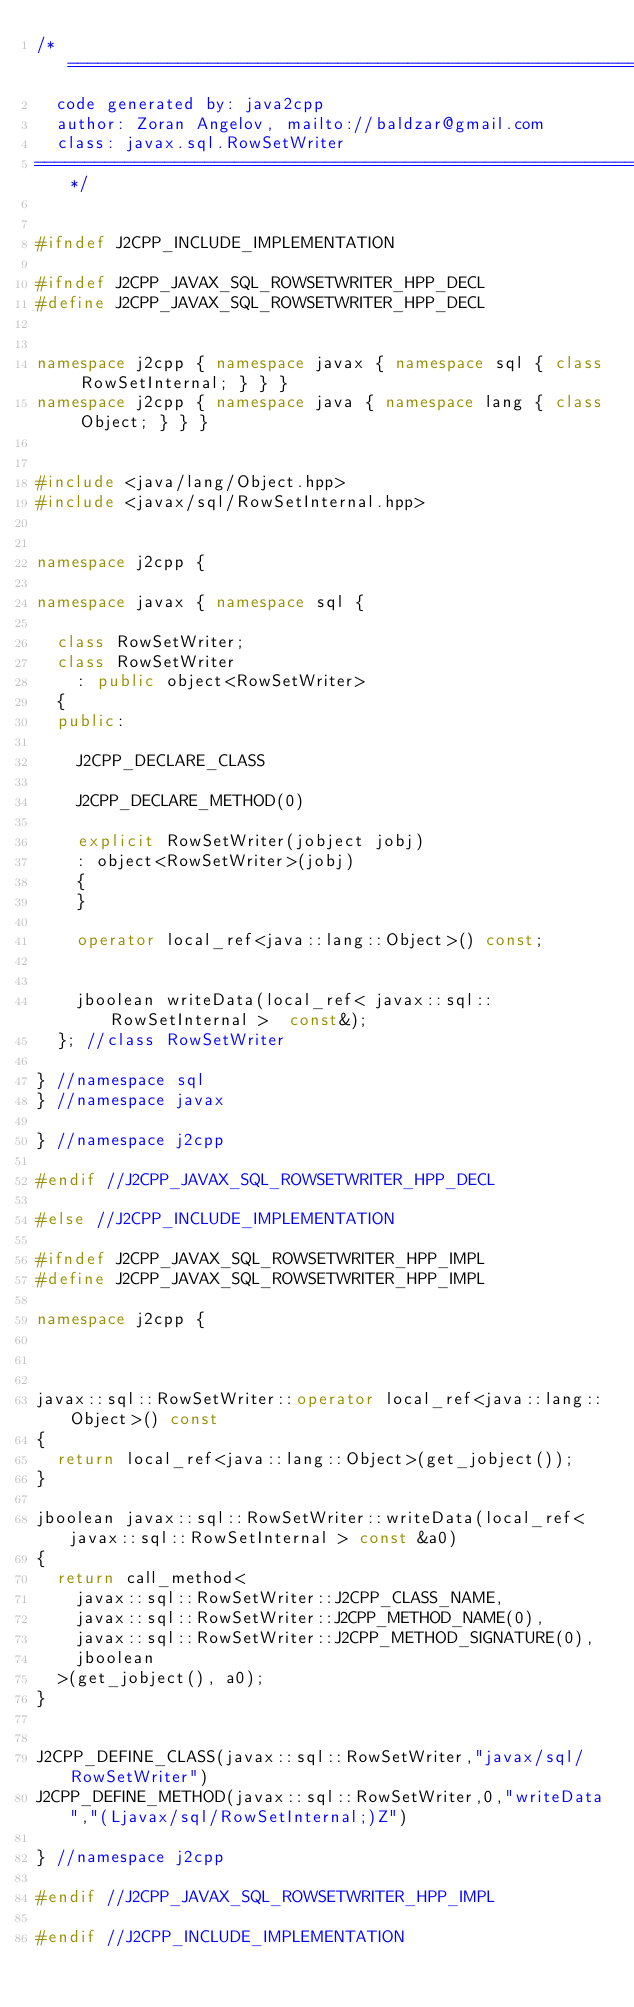Convert code to text. <code><loc_0><loc_0><loc_500><loc_500><_C++_>/*================================================================================
  code generated by: java2cpp
  author: Zoran Angelov, mailto://baldzar@gmail.com
  class: javax.sql.RowSetWriter
================================================================================*/


#ifndef J2CPP_INCLUDE_IMPLEMENTATION

#ifndef J2CPP_JAVAX_SQL_ROWSETWRITER_HPP_DECL
#define J2CPP_JAVAX_SQL_ROWSETWRITER_HPP_DECL


namespace j2cpp { namespace javax { namespace sql { class RowSetInternal; } } }
namespace j2cpp { namespace java { namespace lang { class Object; } } }


#include <java/lang/Object.hpp>
#include <javax/sql/RowSetInternal.hpp>


namespace j2cpp {

namespace javax { namespace sql {

	class RowSetWriter;
	class RowSetWriter
		: public object<RowSetWriter>
	{
	public:

		J2CPP_DECLARE_CLASS

		J2CPP_DECLARE_METHOD(0)

		explicit RowSetWriter(jobject jobj)
		: object<RowSetWriter>(jobj)
		{
		}

		operator local_ref<java::lang::Object>() const;


		jboolean writeData(local_ref< javax::sql::RowSetInternal >  const&);
	}; //class RowSetWriter

} //namespace sql
} //namespace javax

} //namespace j2cpp

#endif //J2CPP_JAVAX_SQL_ROWSETWRITER_HPP_DECL

#else //J2CPP_INCLUDE_IMPLEMENTATION

#ifndef J2CPP_JAVAX_SQL_ROWSETWRITER_HPP_IMPL
#define J2CPP_JAVAX_SQL_ROWSETWRITER_HPP_IMPL

namespace j2cpp {



javax::sql::RowSetWriter::operator local_ref<java::lang::Object>() const
{
	return local_ref<java::lang::Object>(get_jobject());
}

jboolean javax::sql::RowSetWriter::writeData(local_ref< javax::sql::RowSetInternal > const &a0)
{
	return call_method<
		javax::sql::RowSetWriter::J2CPP_CLASS_NAME,
		javax::sql::RowSetWriter::J2CPP_METHOD_NAME(0),
		javax::sql::RowSetWriter::J2CPP_METHOD_SIGNATURE(0), 
		jboolean
	>(get_jobject(), a0);
}


J2CPP_DEFINE_CLASS(javax::sql::RowSetWriter,"javax/sql/RowSetWriter")
J2CPP_DEFINE_METHOD(javax::sql::RowSetWriter,0,"writeData","(Ljavax/sql/RowSetInternal;)Z")

} //namespace j2cpp

#endif //J2CPP_JAVAX_SQL_ROWSETWRITER_HPP_IMPL

#endif //J2CPP_INCLUDE_IMPLEMENTATION
</code> 